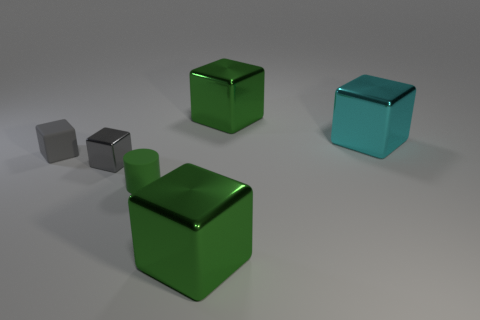What number of other objects are there of the same size as the cyan shiny object?
Provide a succinct answer. 2. There is a big object that is in front of the green rubber cylinder; what is its color?
Give a very brief answer. Green. Does the rubber cylinder have the same size as the cyan cube?
Make the answer very short. No. There is a big block to the right of the big green object behind the big cyan cube; what is its material?
Provide a short and direct response. Metal. What number of small rubber cylinders have the same color as the small metallic block?
Your response must be concise. 0. Is there any other thing that is the same material as the cylinder?
Ensure brevity in your answer.  Yes. Are there fewer green cylinders that are left of the green matte object than green shiny blocks?
Provide a succinct answer. Yes. What color is the metal cube that is on the right side of the large green thing behind the small green matte object?
Ensure brevity in your answer.  Cyan. What size is the green cylinder that is left of the big cube in front of the tiny rubber thing that is behind the green rubber cylinder?
Ensure brevity in your answer.  Small. Is the number of blocks on the right side of the small gray matte block less than the number of big cyan shiny things behind the big cyan metallic cube?
Provide a succinct answer. No. 